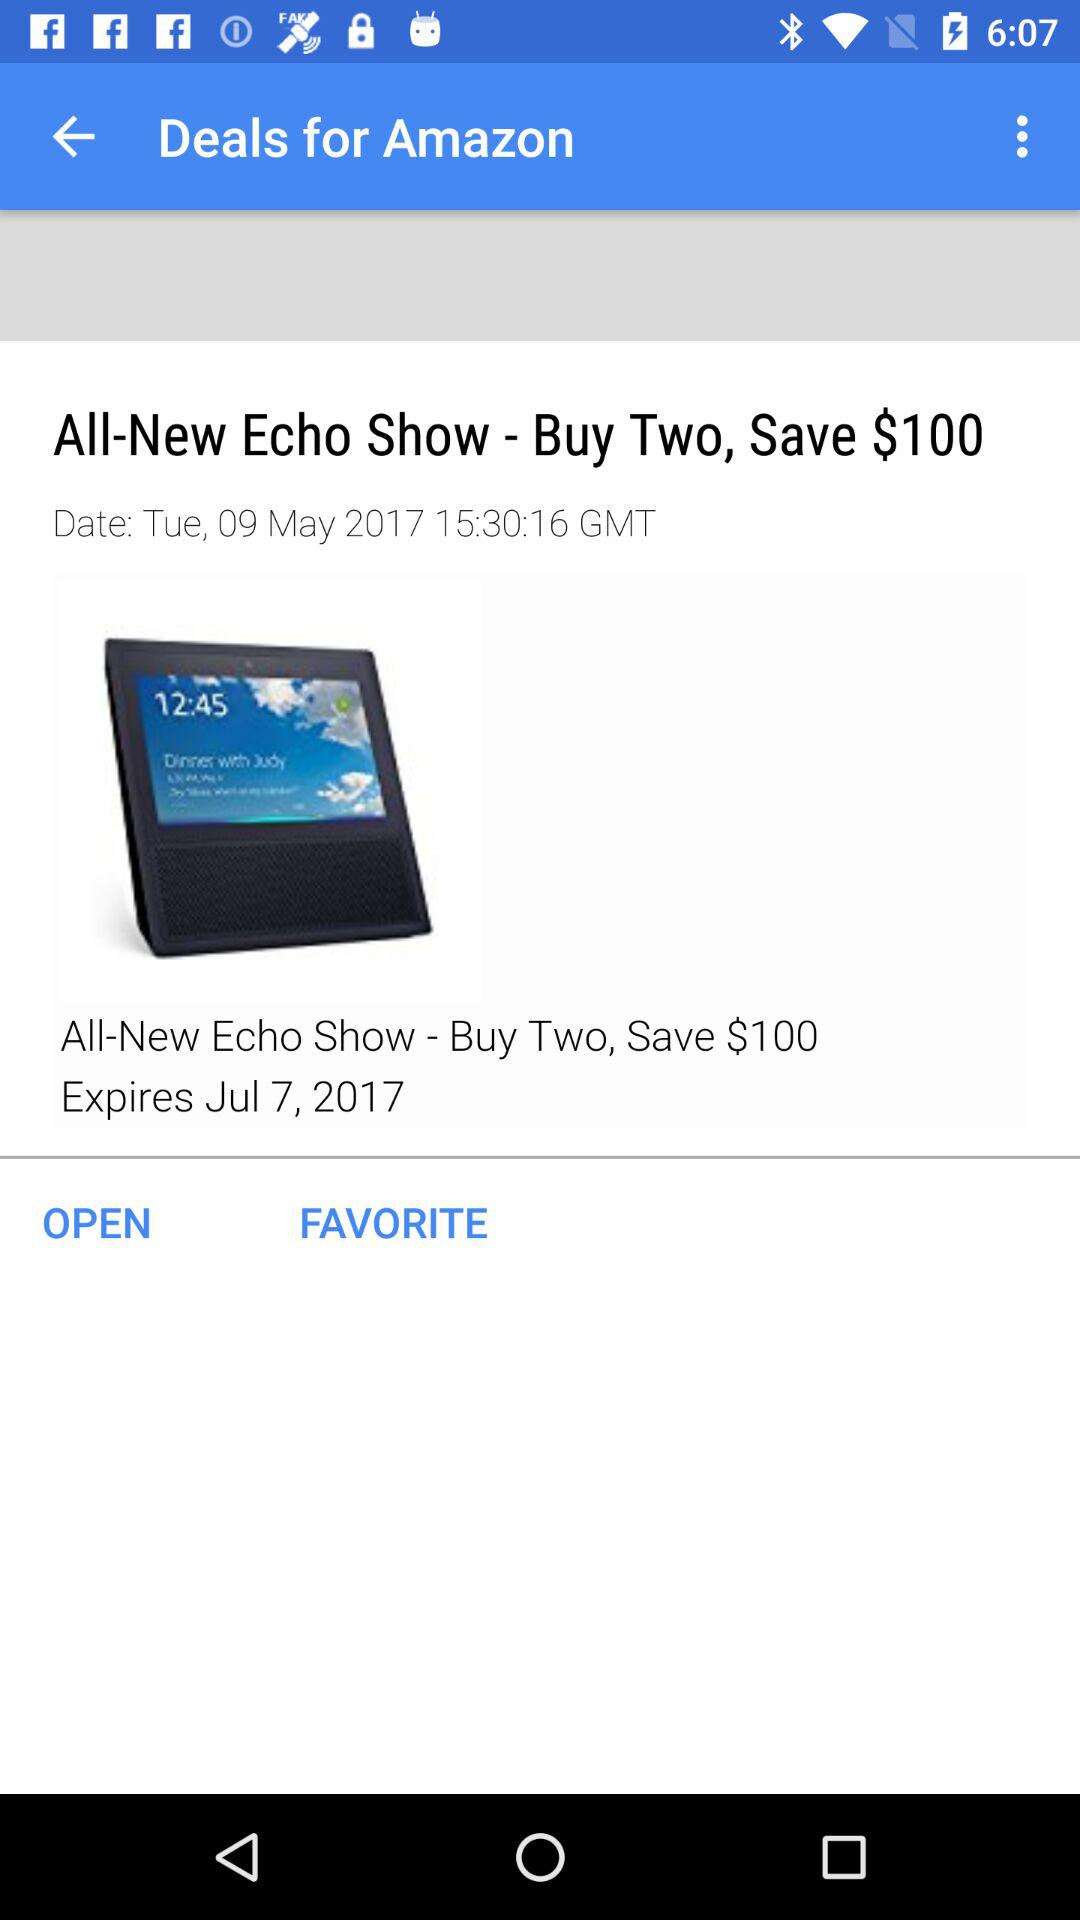How much money can I save by buying two Echo Shows?
Answer the question using a single word or phrase. $100 